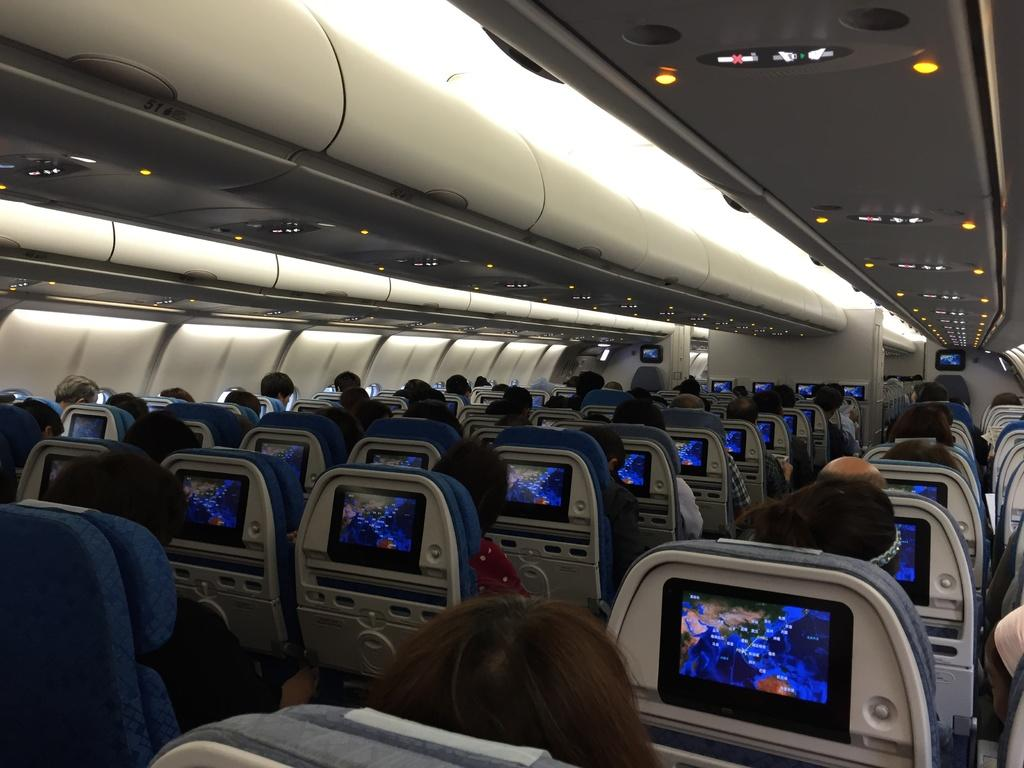What are the people in the image doing? The people in the image are sitting on chairs. What is unique about the chairs in the image? Each chair has a screen on its back. What can be seen at the top of the image? There are lights visible at the top of the image. What type of sock is the person wearing on their left foot in the image? There is no information about socks or feet in the image, so it cannot be determined. 